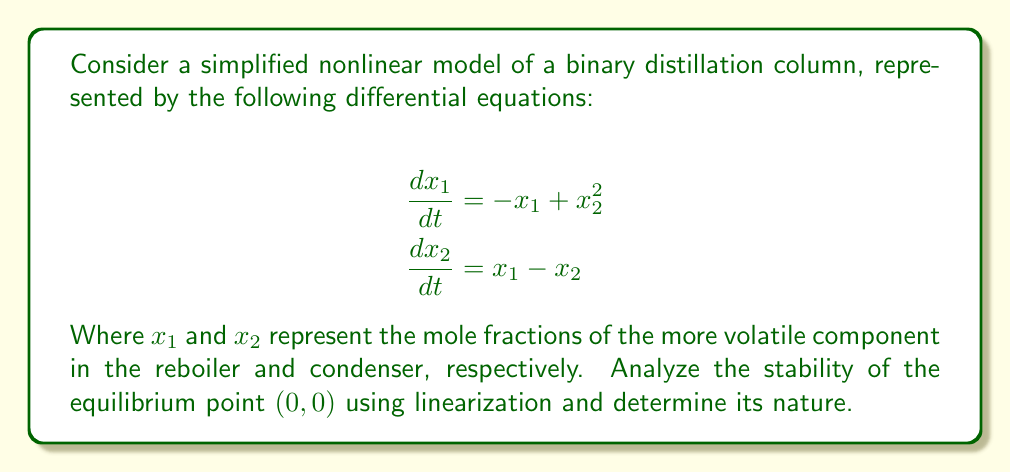Help me with this question. To analyze the stability of the equilibrium point $(0,0)$, we'll follow these steps:

1. Find the Jacobian matrix of the system:
   The Jacobian matrix $J$ is given by:
   $$J = \begin{bmatrix}
   \frac{\partial f_1}{\partial x_1} & \frac{\partial f_1}{\partial x_2} \\
   \frac{\partial f_2}{\partial x_1} & \frac{\partial f_2}{\partial x_2}
   \end{bmatrix}$$

   Where $f_1 = -x_1 + x_2^2$ and $f_2 = x_1 - x_2$

   $$J = \begin{bmatrix}
   -1 & 2x_2 \\
   1 & -1
   \end{bmatrix}$$

2. Evaluate the Jacobian at the equilibrium point $(0,0)$:
   $$J_{(0,0)} = \begin{bmatrix}
   -1 & 0 \\
   1 & -1
   \end{bmatrix}$$

3. Find the eigenvalues of $J_{(0,0)}$:
   The characteristic equation is:
   $$\det(J_{(0,0)} - \lambda I) = 0$$
   $$\begin{vmatrix}
   -1-\lambda & 0 \\
   1 & -1-\lambda
   \end{vmatrix} = 0$$
   $$(-1-\lambda)(-1-\lambda) = 0$$
   $$\lambda^2 + 2\lambda + 1 = 0$$

   Solving this quadratic equation:
   $$\lambda = \frac{-2 \pm \sqrt{4-4}}{2} = -1$$

4. Interpret the eigenvalues:
   Both eigenvalues are real and negative $(\lambda_1 = \lambda_2 = -1)$. This indicates that the equilibrium point $(0,0)$ is asymptotically stable.

5. Determine the nature of the equilibrium point:
   Since both eigenvalues are equal and negative, the equilibrium point is a stable node. Trajectories in the phase plane will approach the origin directly without spiraling.
Answer: Asymptotically stable node 